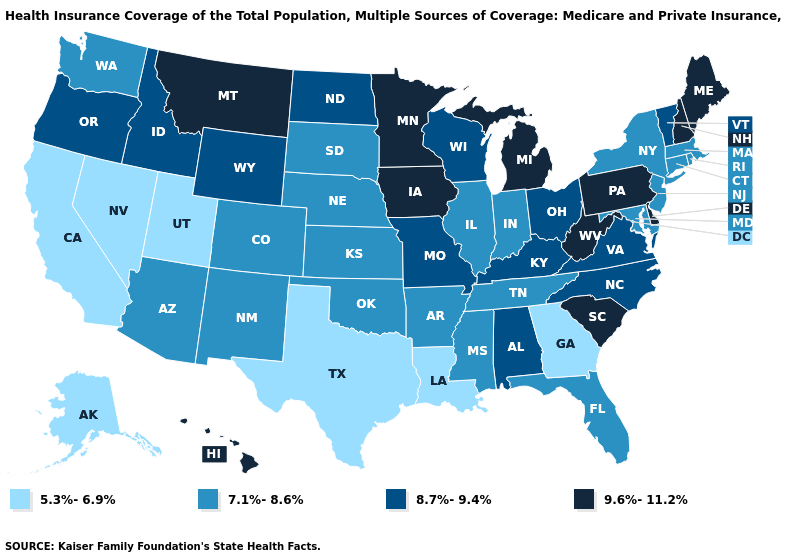Is the legend a continuous bar?
Give a very brief answer. No. Which states have the lowest value in the USA?
Give a very brief answer. Alaska, California, Georgia, Louisiana, Nevada, Texas, Utah. Name the states that have a value in the range 5.3%-6.9%?
Give a very brief answer. Alaska, California, Georgia, Louisiana, Nevada, Texas, Utah. Name the states that have a value in the range 5.3%-6.9%?
Quick response, please. Alaska, California, Georgia, Louisiana, Nevada, Texas, Utah. What is the value of Washington?
Short answer required. 7.1%-8.6%. What is the value of New Hampshire?
Quick response, please. 9.6%-11.2%. What is the value of South Carolina?
Give a very brief answer. 9.6%-11.2%. Which states have the lowest value in the West?
Keep it brief. Alaska, California, Nevada, Utah. What is the value of Connecticut?
Concise answer only. 7.1%-8.6%. Does Nebraska have a lower value than Arizona?
Short answer required. No. Is the legend a continuous bar?
Be succinct. No. How many symbols are there in the legend?
Quick response, please. 4. What is the highest value in the USA?
Answer briefly. 9.6%-11.2%. Among the states that border Kentucky , which have the lowest value?
Write a very short answer. Illinois, Indiana, Tennessee. Which states have the lowest value in the USA?
Concise answer only. Alaska, California, Georgia, Louisiana, Nevada, Texas, Utah. 